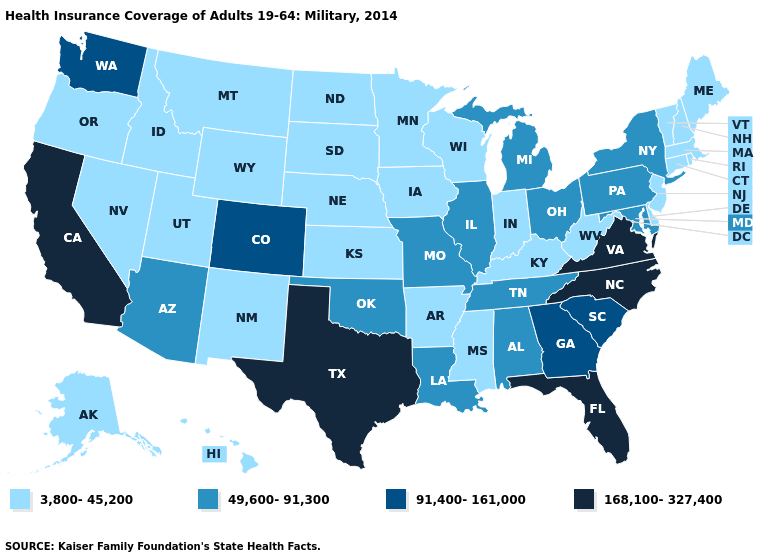Does Wyoming have the highest value in the USA?
Short answer required. No. Does Texas have the highest value in the USA?
Keep it brief. Yes. Does the map have missing data?
Write a very short answer. No. What is the value of Maine?
Answer briefly. 3,800-45,200. How many symbols are there in the legend?
Be succinct. 4. Which states have the lowest value in the USA?
Be succinct. Alaska, Arkansas, Connecticut, Delaware, Hawaii, Idaho, Indiana, Iowa, Kansas, Kentucky, Maine, Massachusetts, Minnesota, Mississippi, Montana, Nebraska, Nevada, New Hampshire, New Jersey, New Mexico, North Dakota, Oregon, Rhode Island, South Dakota, Utah, Vermont, West Virginia, Wisconsin, Wyoming. Does Georgia have the same value as New Jersey?
Concise answer only. No. Does the first symbol in the legend represent the smallest category?
Concise answer only. Yes. Among the states that border California , does Arizona have the highest value?
Short answer required. Yes. How many symbols are there in the legend?
Short answer required. 4. Which states hav the highest value in the South?
Keep it brief. Florida, North Carolina, Texas, Virginia. Does Oklahoma have the lowest value in the South?
Answer briefly. No. Does Arizona have the lowest value in the USA?
Give a very brief answer. No. What is the lowest value in states that border Georgia?
Quick response, please. 49,600-91,300. Does Wisconsin have the highest value in the MidWest?
Answer briefly. No. 